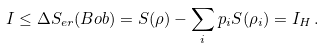<formula> <loc_0><loc_0><loc_500><loc_500>I \leq \Delta S _ { e r } ( B o b ) = S ( \rho ) - \sum _ { i } p _ { i } S ( \rho _ { i } ) = I _ { H } \, .</formula> 